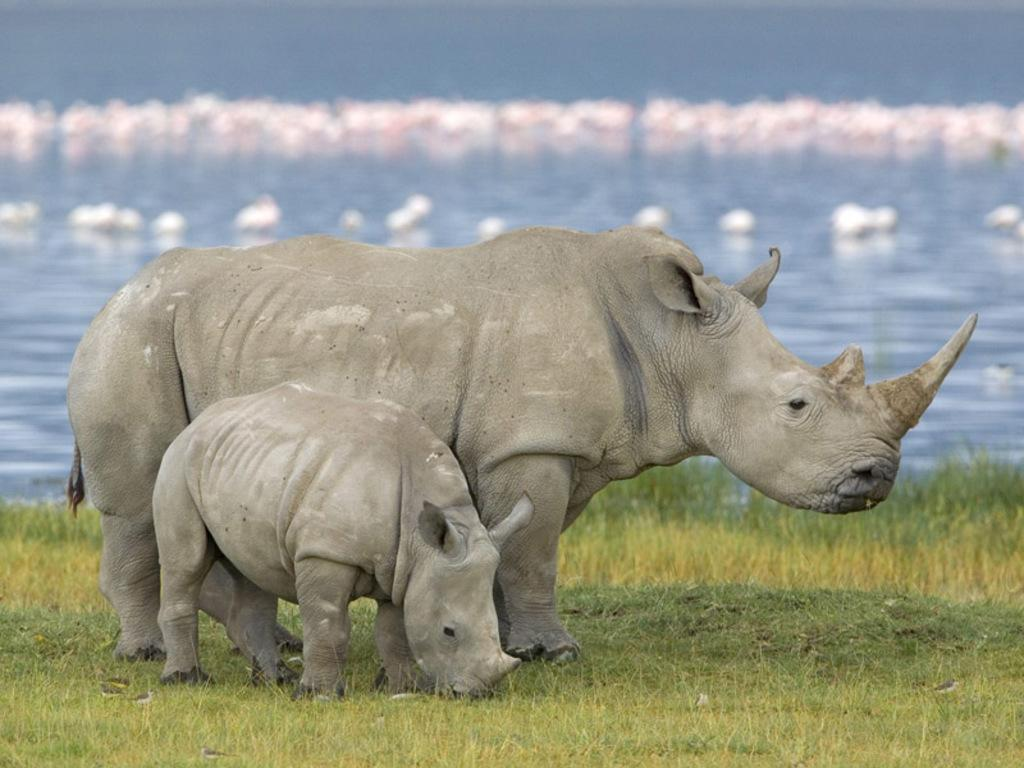What is located in the center of the image? There are animals in the center of the image. What type of terrain is visible at the bottom of the image? There is grass at the bottom of the image. What can be seen in the background of the image? There is water and ducks visible in the background of the image. What type of crack is visible on the edge of the image? There is no crack visible on the edge of the image. What color is the sweater worn by the animals in the image? The animals in the image do not appear to be wearing any clothing, including sweaters. 